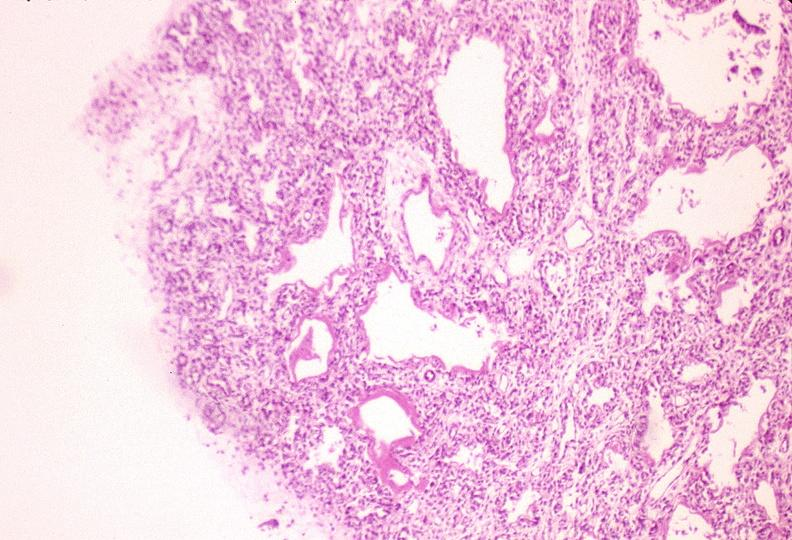does muscle show lungs, hyaline membrane disease?
Answer the question using a single word or phrase. No 